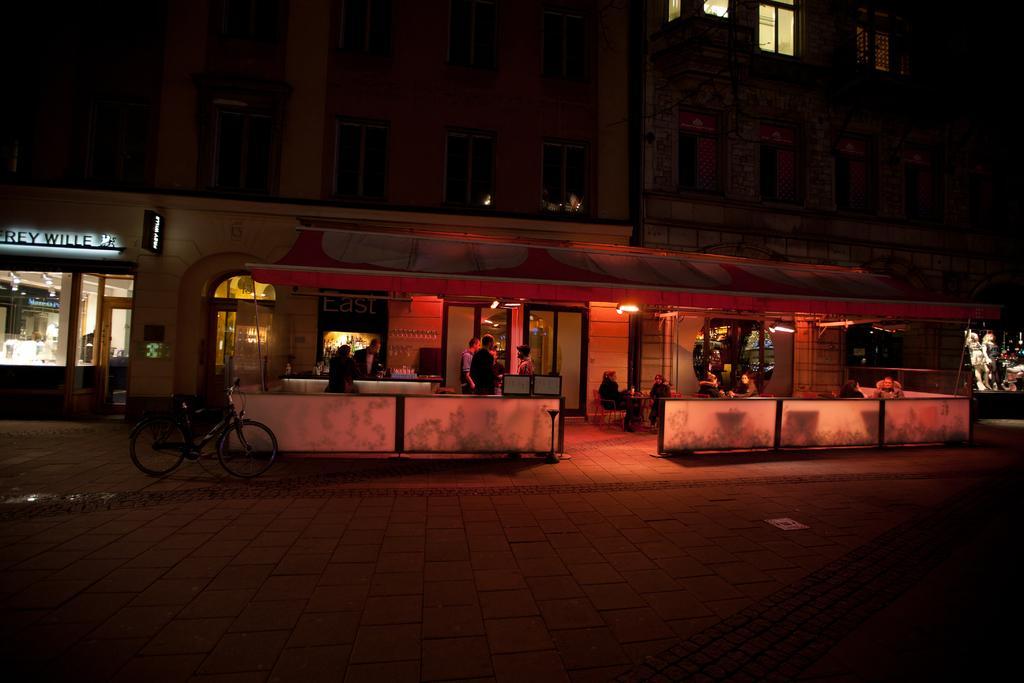In one or two sentences, can you explain what this image depicts? This image consists of a building. It has windows. In the middle it looks like a store. There are some persons standing in the middle. There are lights in the middle. There is a bicycle on the left side. 